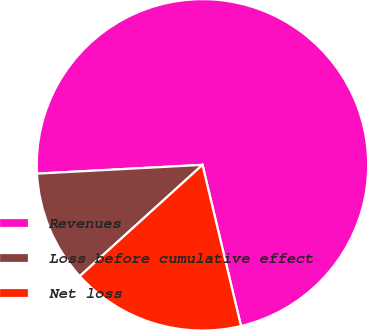Convert chart to OTSL. <chart><loc_0><loc_0><loc_500><loc_500><pie_chart><fcel>Revenues<fcel>Loss before cumulative effect<fcel>Net loss<nl><fcel>72.11%<fcel>10.88%<fcel>17.01%<nl></chart> 